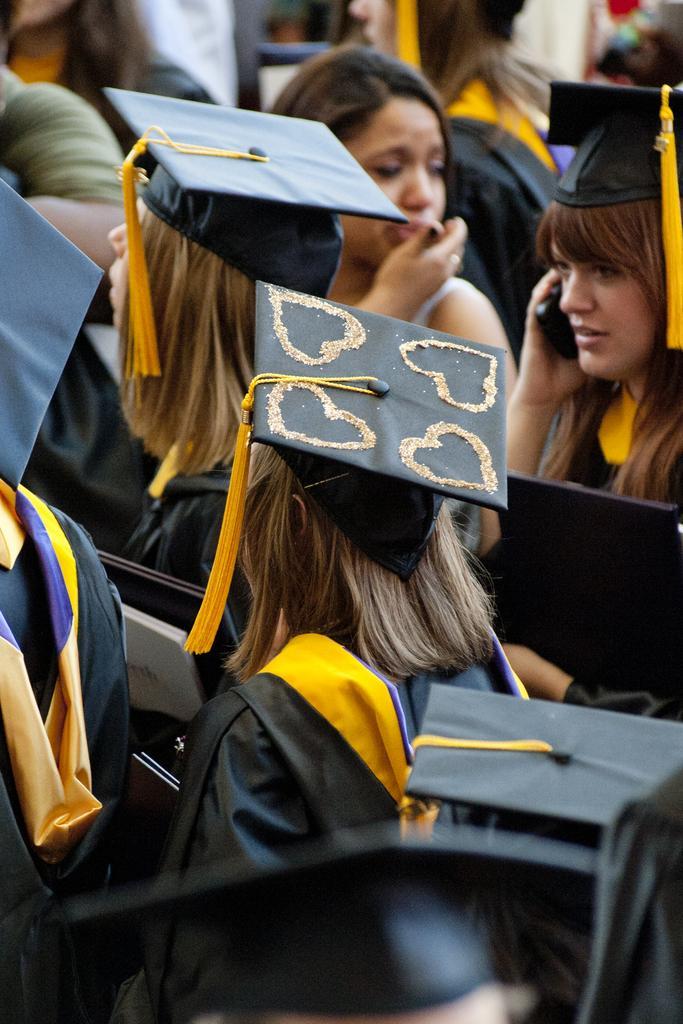In one or two sentences, can you explain what this image depicts? In this image I can see number of persons wearing black and yellow colored dresses and holding few objects. I can see the blurry background. 